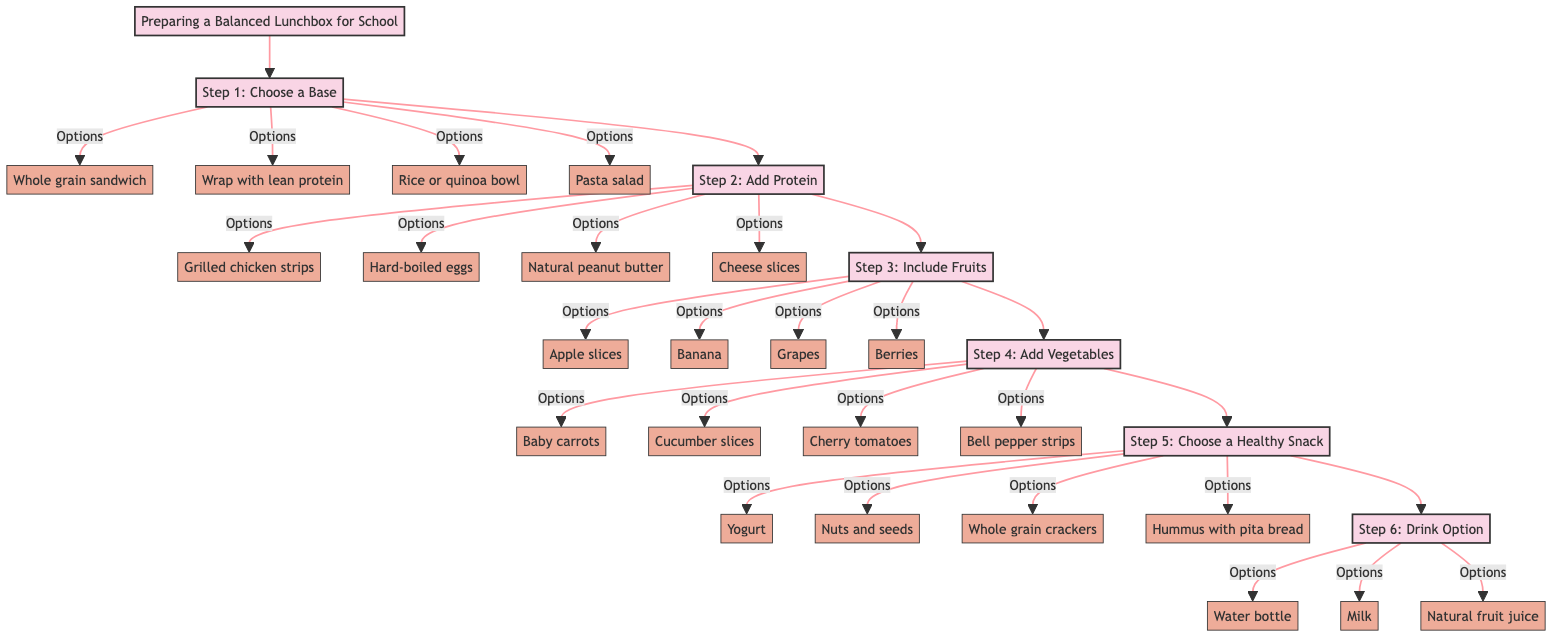What is the first step in preparing a balanced lunchbox? The first step in the diagram is labeled "Step 1: Choose a Base," which indicates that you should start with a main food item for the lunchbox.
Answer: Step 1: Choose a Base How many options are provided for adding protein? In "Step 2: Add Protein," there are four options listed, which are grilled chicken strips, hard-boiled eggs, natural peanut butter, and cheese slices.
Answer: 4 What type of drink option is included in the last step? The last step, "Step 6: Drink Option," includes water bottle, milk, and natural fruit juice (limited) as the drink options for the lunchbox.
Answer: Water bottle, Milk, Natural fruit juice Which step includes including fresh fruits? "Step 3: Include Fruits" specifically points out the need to incorporate fresh fruits, making it a dedicated step for this purpose.
Answer: Step 3: Include Fruits What is the total number of steps in preparing the lunchbox? The diagram has a total of six steps outlined in the preparation process for a balanced lunchbox, starting from choosing a base to selecting a drink option.
Answer: 6 What are the options listed for vegetables in Step 4? In "Step 4: Add Vegetables," four options are given: baby carrots, cucumber slices, cherry tomatoes, and bell pepper strips.
Answer: Baby carrots, Cucumber slices, Cherry tomatoes, Bell pepper strips What is a tip mentioned for making the lunchbox preparation eco-friendly? One of the additional tips advises using reusable containers to promote an eco-friendly approach while preparing the lunchbox.
Answer: Use reusable containers How do you choose the healthy snack in Step 5? "Step 5: Choose a Healthy Snack" instructs to select one of the four options available, which include yogurt, nuts and seeds, whole grain crackers, and hummus with pita bread.
Answer: Choose one of the four options What is the main focus of Step 2? The main focus of "Step 2: Add Protein" is to include a healthy source of protein in the lunchbox to ensure the child feels full and energized.
Answer: Add Protein 